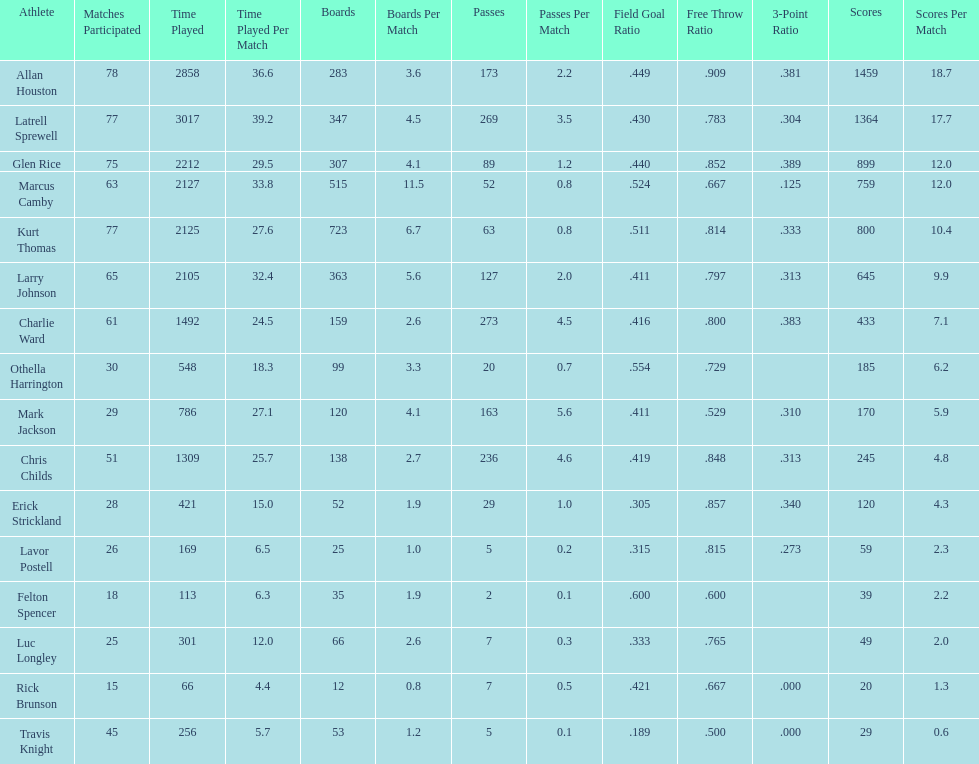How many more games did allan houston play than mark jackson? 49. 